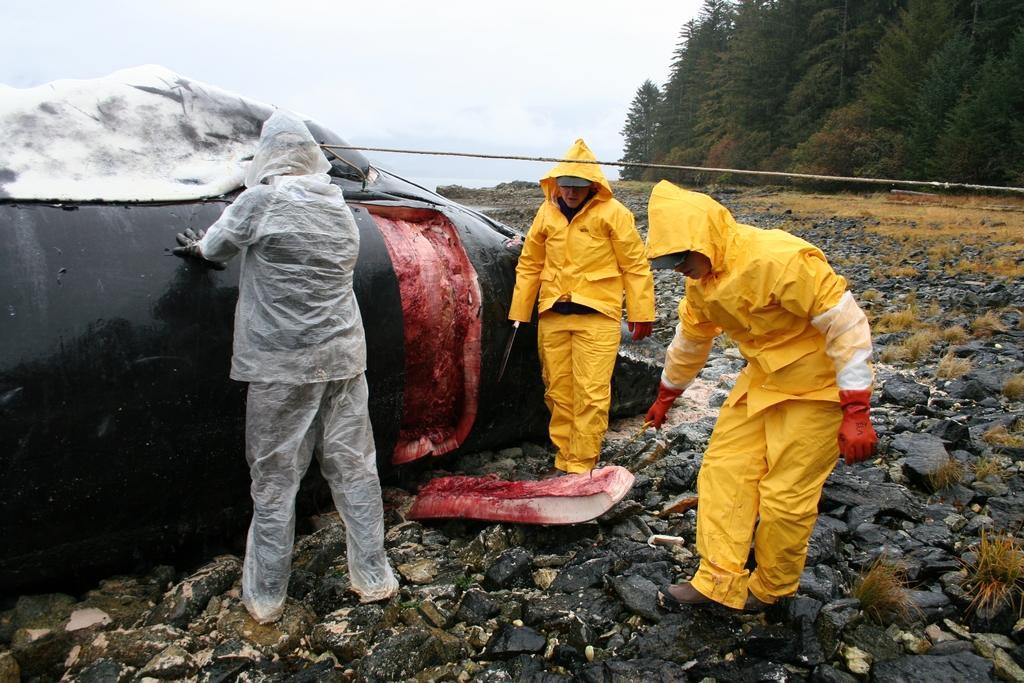How would you summarize this image in a sentence or two? In the image we can see there is an animal lying on the ground and its flesh is on the ground. There are stones on the ground and there is rope. There are three people standing and they are wearing plastic suits. Behind there are trees and the sky is clear. 